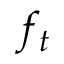Convert formula to latex. <formula><loc_0><loc_0><loc_500><loc_500>f _ { t }</formula> 